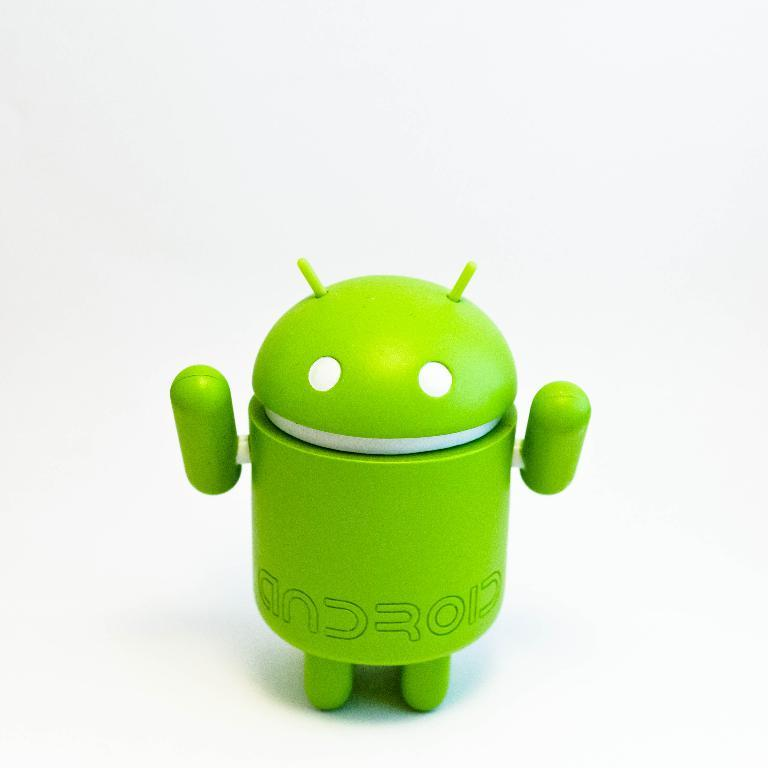<image>
Render a clear and concise summary of the photo. a green android figure on a white surface 